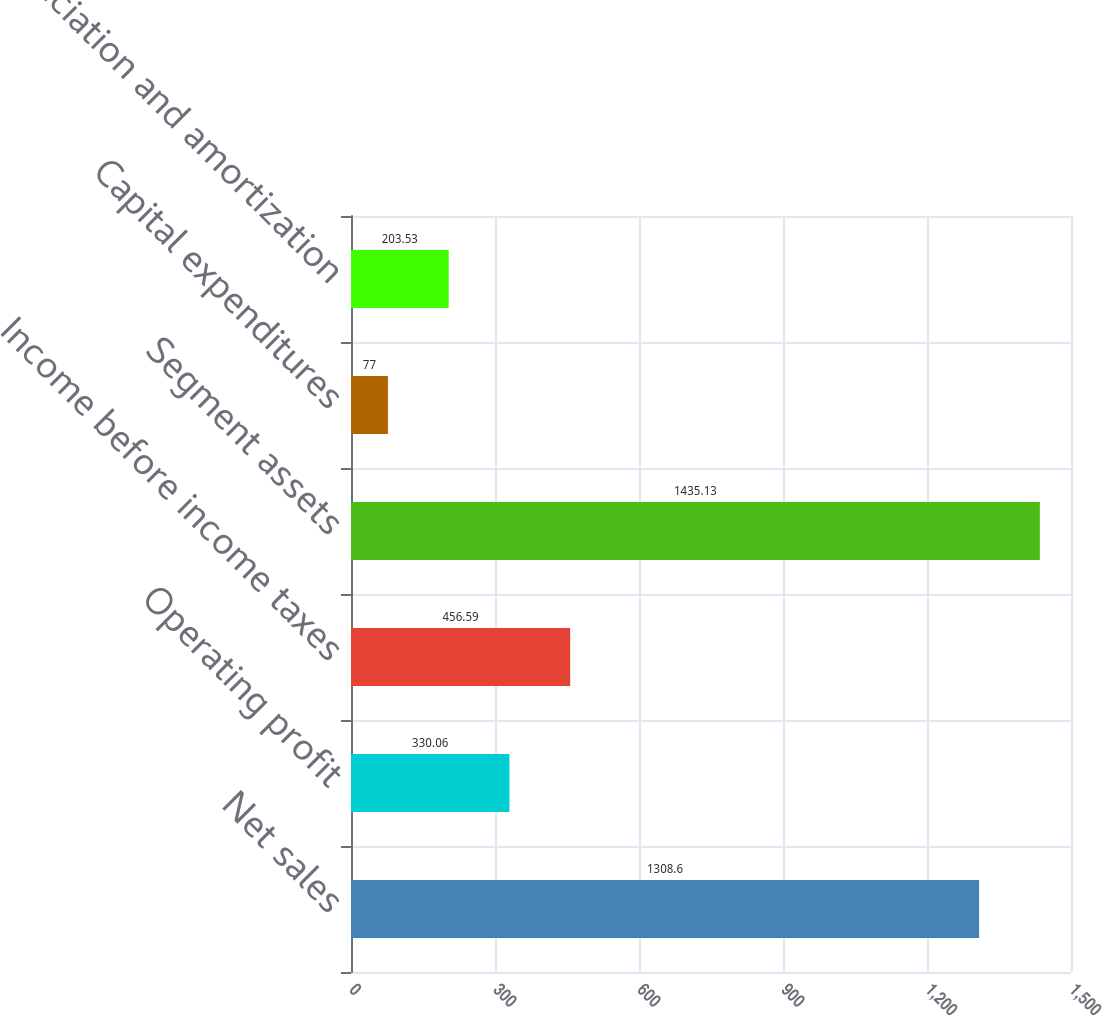<chart> <loc_0><loc_0><loc_500><loc_500><bar_chart><fcel>Net sales<fcel>Operating profit<fcel>Income before income taxes<fcel>Segment assets<fcel>Capital expenditures<fcel>Depreciation and amortization<nl><fcel>1308.6<fcel>330.06<fcel>456.59<fcel>1435.13<fcel>77<fcel>203.53<nl></chart> 